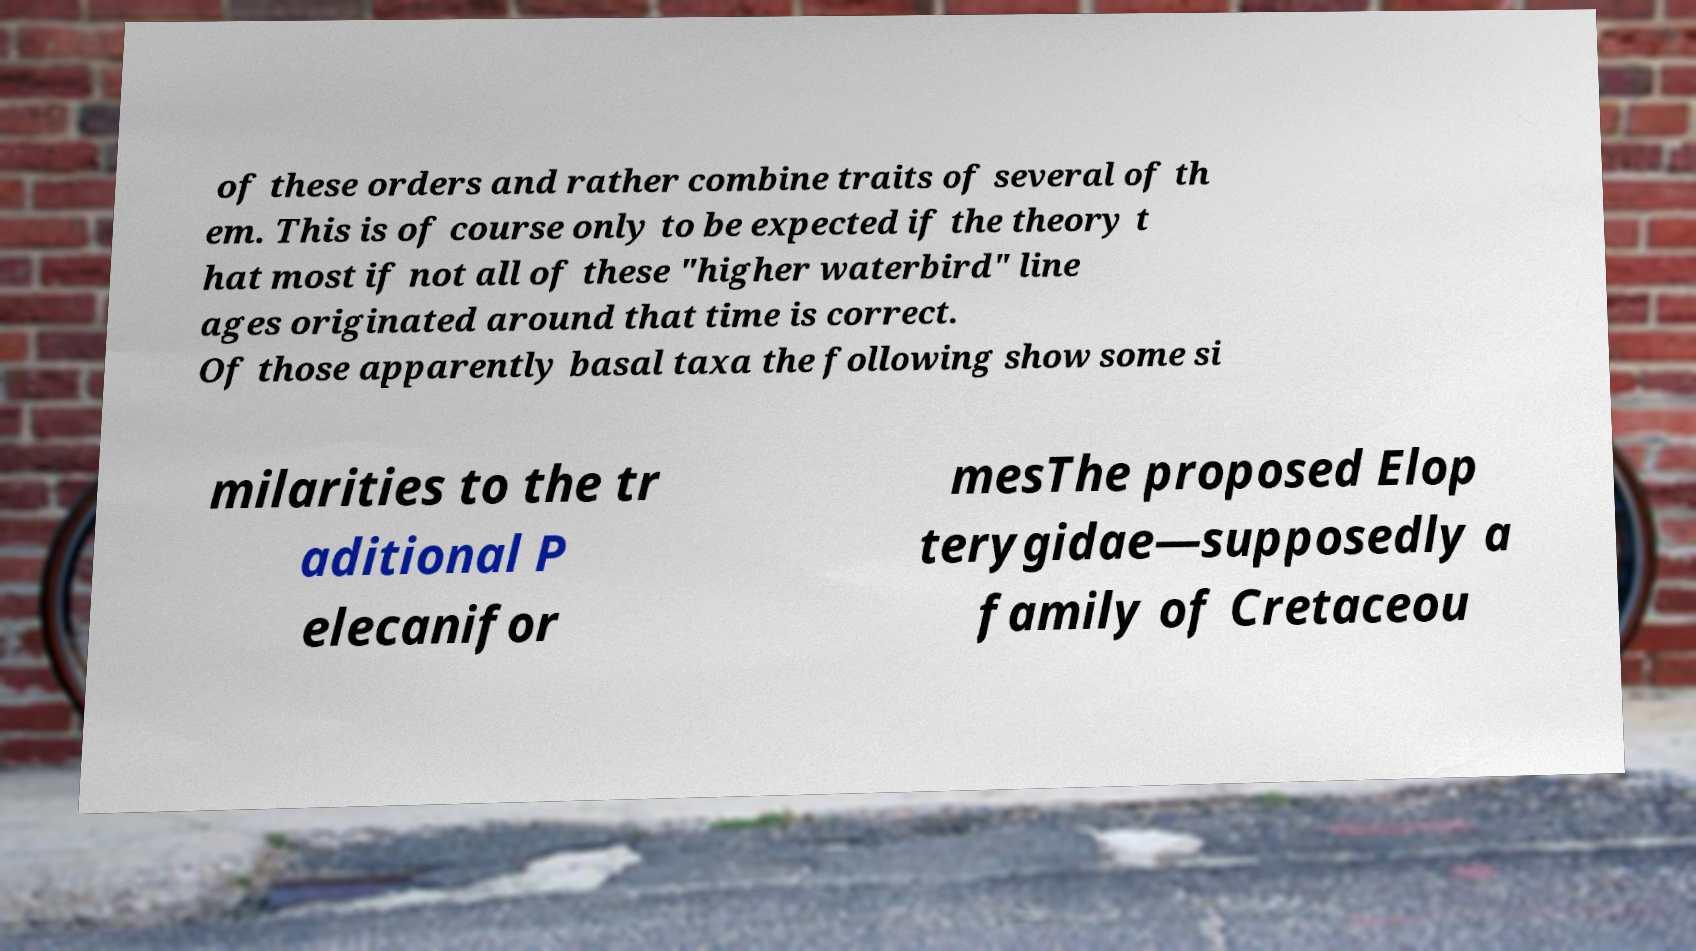I need the written content from this picture converted into text. Can you do that? of these orders and rather combine traits of several of th em. This is of course only to be expected if the theory t hat most if not all of these "higher waterbird" line ages originated around that time is correct. Of those apparently basal taxa the following show some si milarities to the tr aditional P elecanifor mesThe proposed Elop terygidae—supposedly a family of Cretaceou 